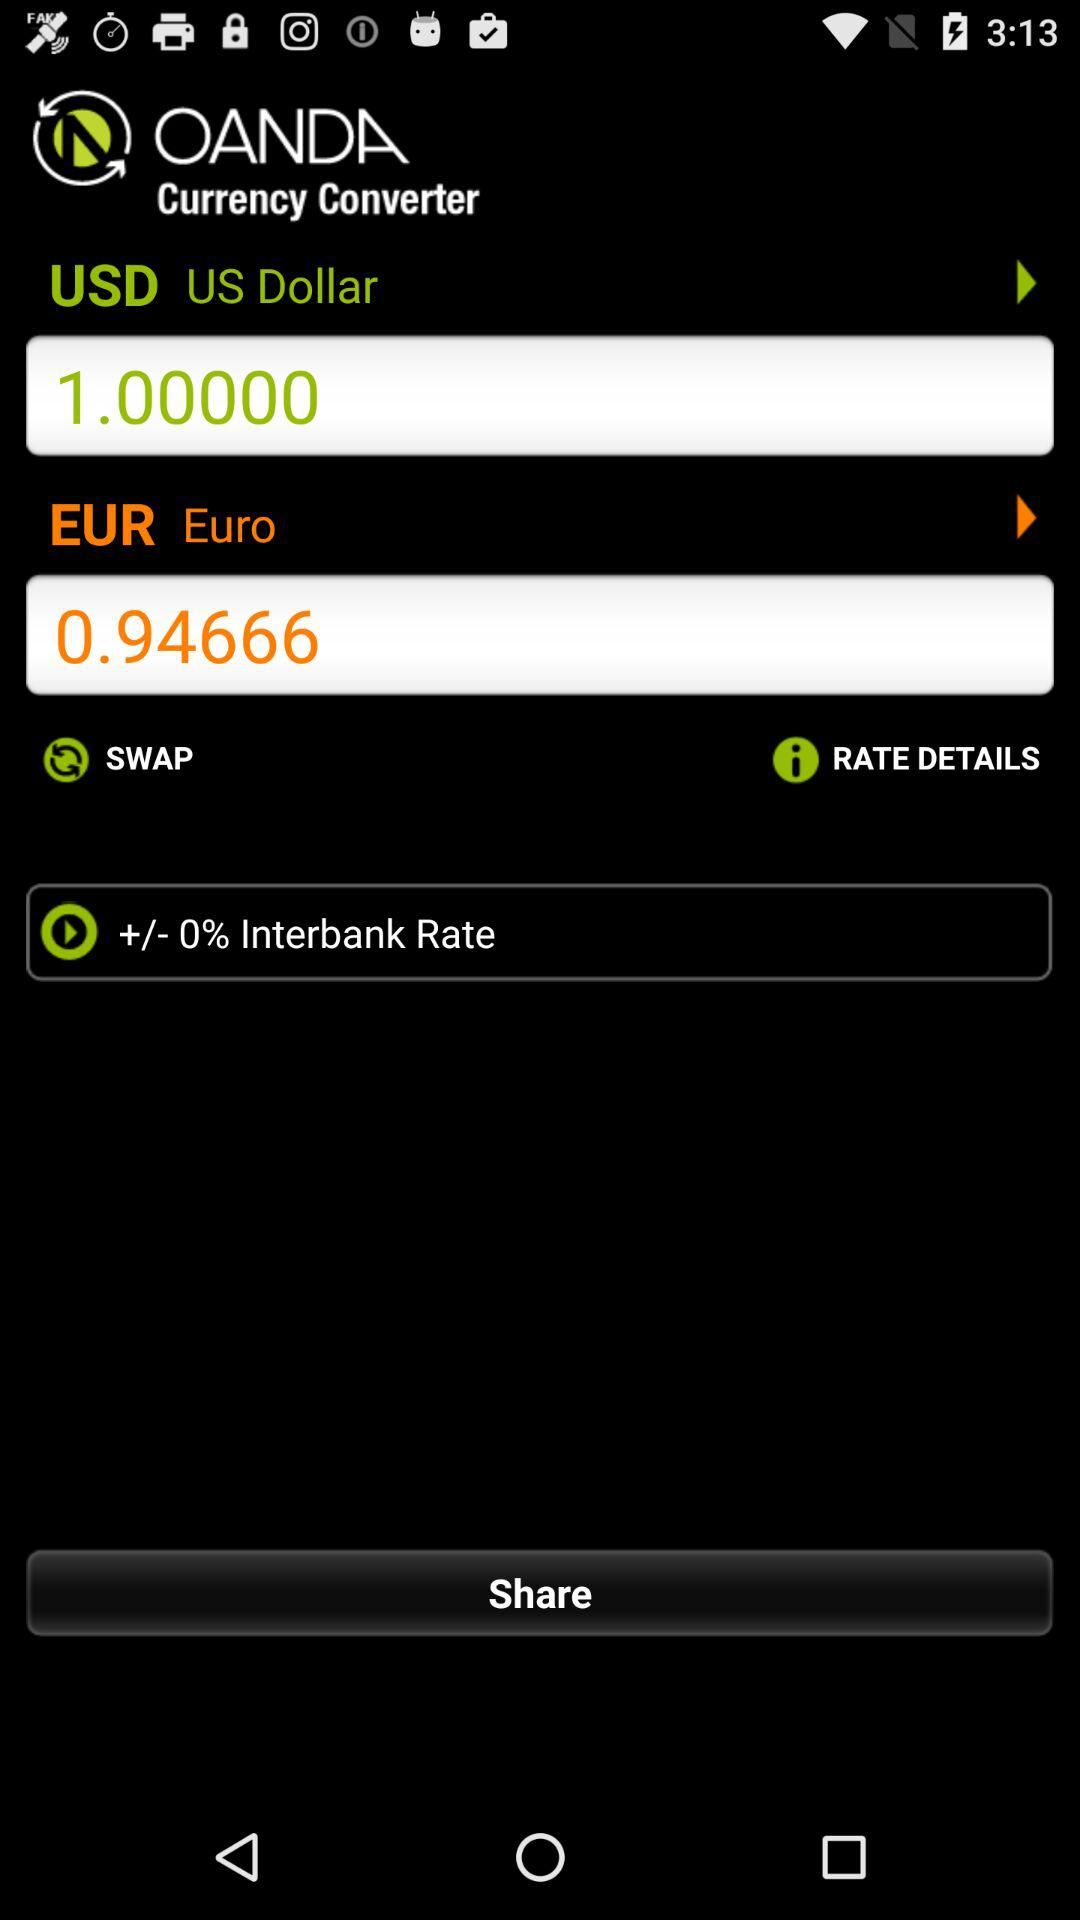How many euros are there in one US dollar? There are 0.94666 euros in one US dollar. 